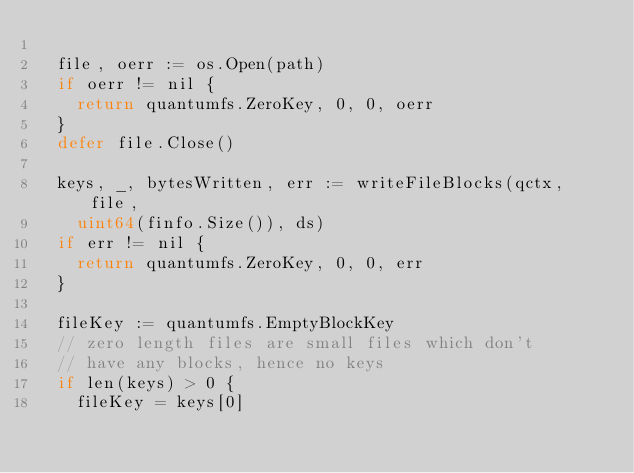<code> <loc_0><loc_0><loc_500><loc_500><_Go_>
	file, oerr := os.Open(path)
	if oerr != nil {
		return quantumfs.ZeroKey, 0, 0, oerr
	}
	defer file.Close()

	keys, _, bytesWritten, err := writeFileBlocks(qctx, file,
		uint64(finfo.Size()), ds)
	if err != nil {
		return quantumfs.ZeroKey, 0, 0, err
	}

	fileKey := quantumfs.EmptyBlockKey
	// zero length files are small files which don't
	// have any blocks, hence no keys
	if len(keys) > 0 {
		fileKey = keys[0]</code> 